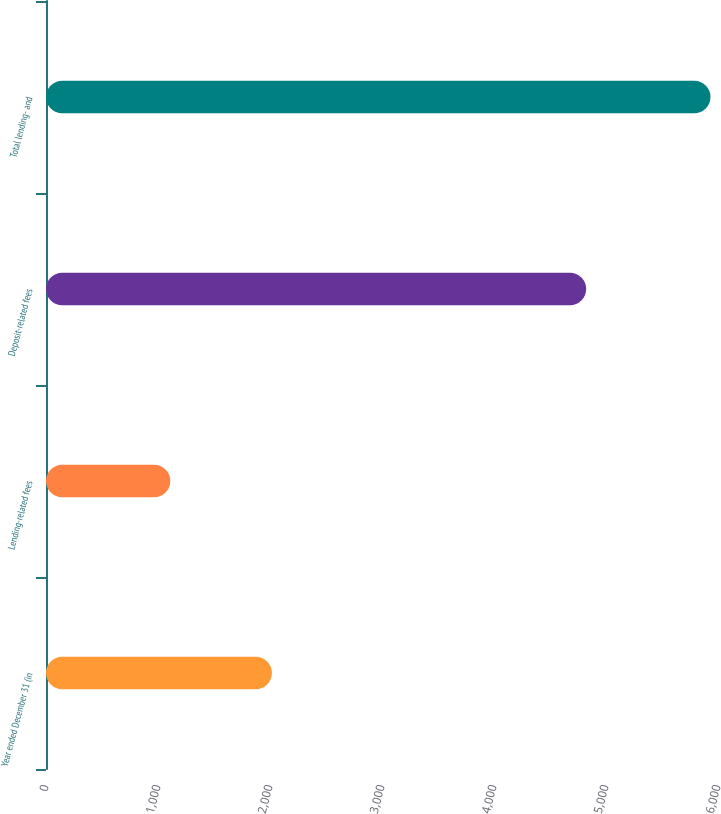Convert chart to OTSL. <chart><loc_0><loc_0><loc_500><loc_500><bar_chart><fcel>Year ended December 31 (in<fcel>Lending-related fees<fcel>Deposit-related fees<fcel>Total lending- and<nl><fcel>2017<fcel>1110<fcel>4823<fcel>5933<nl></chart> 